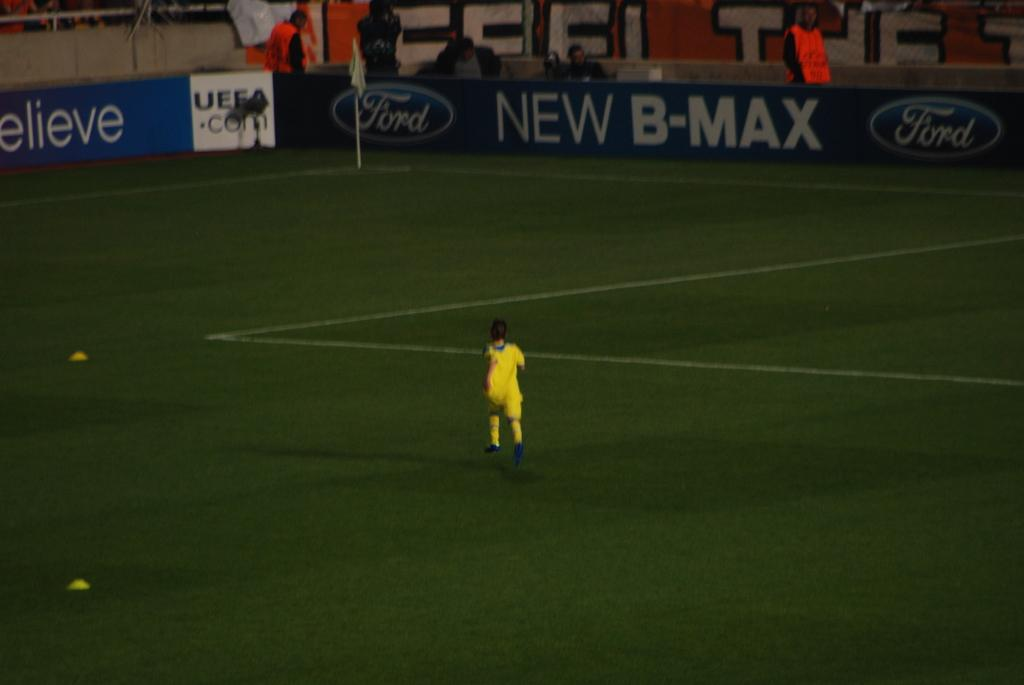<image>
Create a compact narrative representing the image presented. A person in yellow runs on a soccer field which is bordered by a banner from Ford advertising the New B-MAX. 